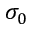<formula> <loc_0><loc_0><loc_500><loc_500>\sigma _ { 0 }</formula> 